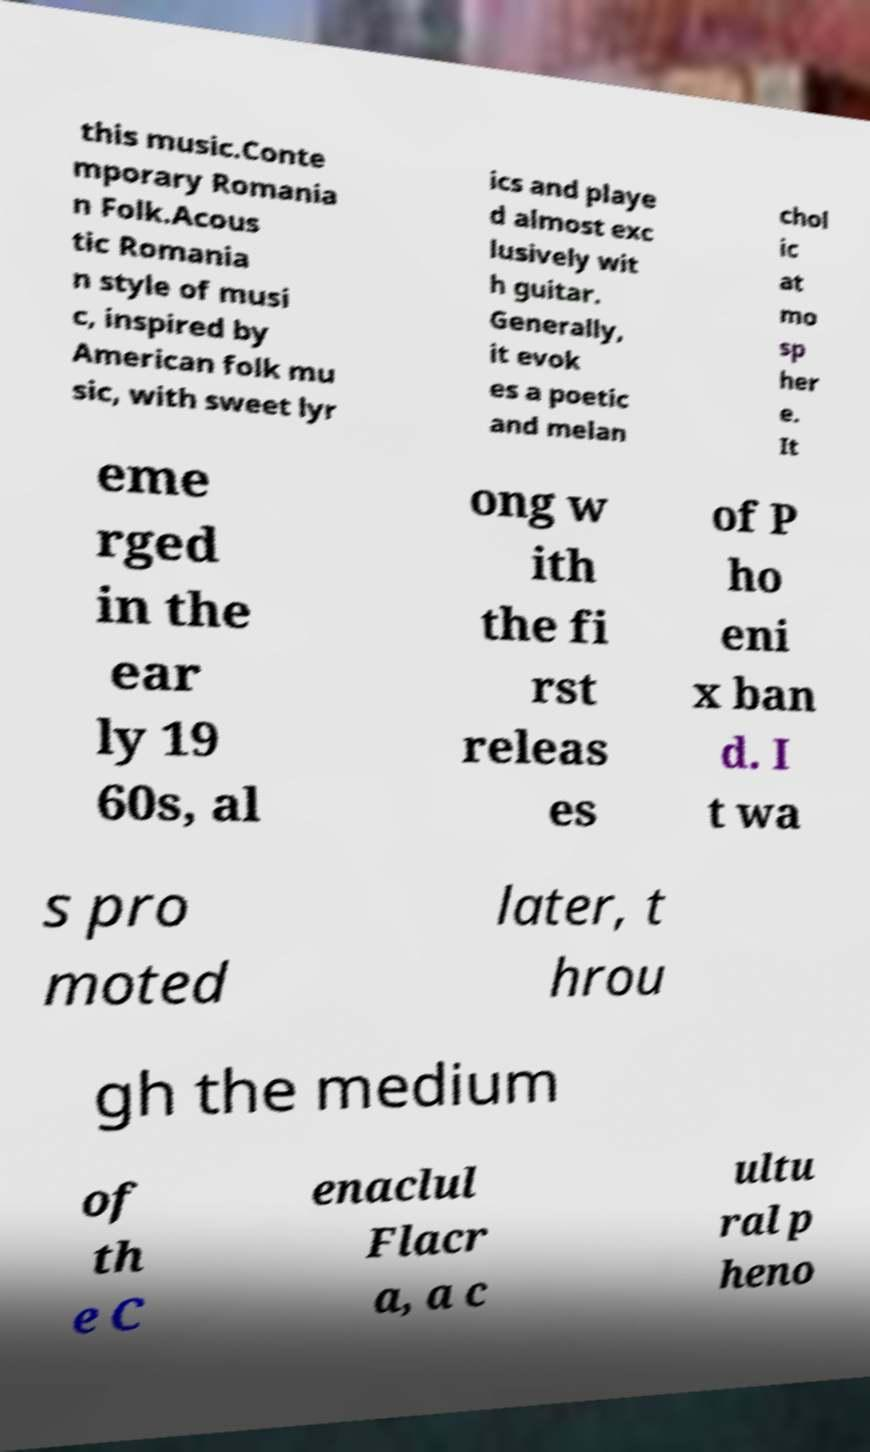Please read and relay the text visible in this image. What does it say? this music.Conte mporary Romania n Folk.Acous tic Romania n style of musi c, inspired by American folk mu sic, with sweet lyr ics and playe d almost exc lusively wit h guitar. Generally, it evok es a poetic and melan chol ic at mo sp her e. It eme rged in the ear ly 19 60s, al ong w ith the fi rst releas es of P ho eni x ban d. I t wa s pro moted later, t hrou gh the medium of th e C enaclul Flacr a, a c ultu ral p heno 